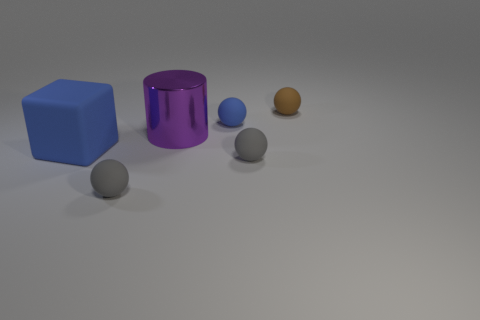What number of other objects are the same shape as the big purple metal object?
Provide a short and direct response. 0. What is the color of the rubber block that is the same size as the purple metallic thing?
Give a very brief answer. Blue. How many cubes are tiny blue things or tiny matte things?
Your answer should be very brief. 0. How many balls are there?
Offer a very short reply. 4. Do the big blue rubber thing and the large object behind the matte cube have the same shape?
Your response must be concise. No. What size is the matte thing that is the same color as the cube?
Keep it short and to the point. Small. How many things are big shiny things or yellow cylinders?
Provide a short and direct response. 1. There is a gray rubber thing that is in front of the tiny gray object that is to the right of the purple object; what is its shape?
Make the answer very short. Sphere. There is a blue thing left of the shiny thing; is it the same shape as the purple object?
Ensure brevity in your answer.  No. There is a blue object that is made of the same material as the big block; what is its size?
Ensure brevity in your answer.  Small. 